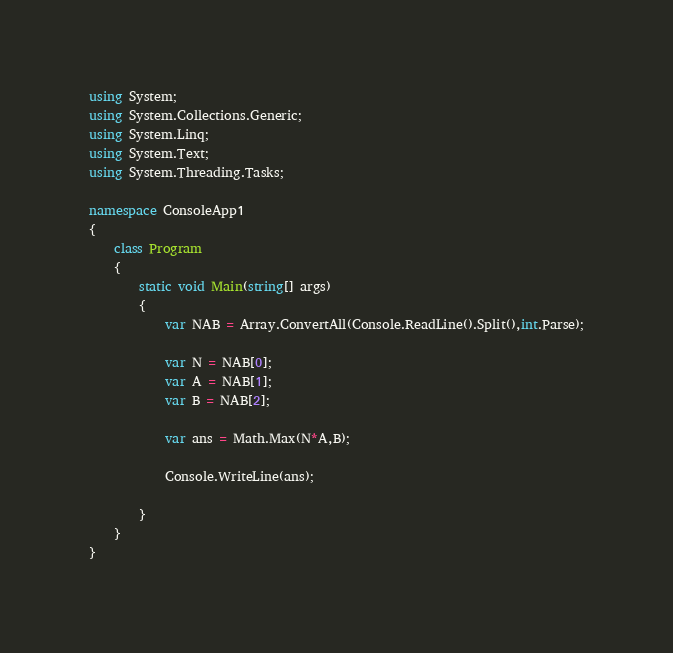Convert code to text. <code><loc_0><loc_0><loc_500><loc_500><_C#_>using System;
using System.Collections.Generic;
using System.Linq;
using System.Text;
using System.Threading.Tasks;

namespace ConsoleApp1
{
    class Program
    {
        static void Main(string[] args)
        {
            var NAB = Array.ConvertAll(Console.ReadLine().Split(),int.Parse);

            var N = NAB[0];
            var A = NAB[1];
            var B = NAB[2];

            var ans = Math.Max(N*A,B);

            Console.WriteLine(ans);

        }
    }
}
</code> 